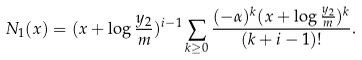<formula> <loc_0><loc_0><loc_500><loc_500>N _ { 1 } ( x ) = ( x + \log \frac { y _ { 2 } } { m } ) ^ { i - 1 } \sum _ { k \geq 0 } \frac { ( - \alpha ) ^ { k } ( x + \log \frac { y _ { 2 } } { m } ) ^ { k } } { ( k + i - 1 ) ! } .</formula> 